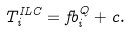Convert formula to latex. <formula><loc_0><loc_0><loc_500><loc_500>T _ { i } ^ { I L C } = f b ^ { Q } _ { i } + c .</formula> 